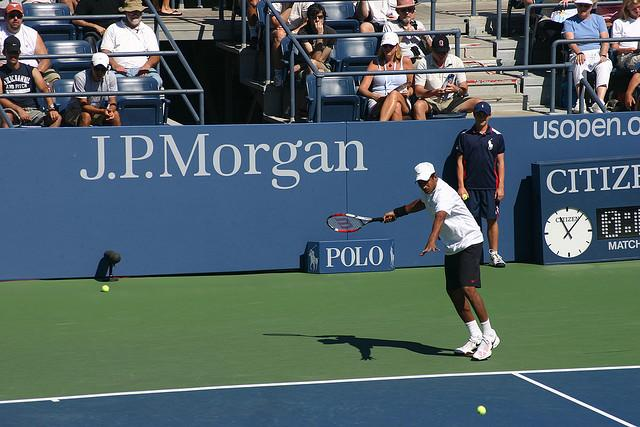What is the finance company advertised on the wall next to the tennis player? jp morgan 